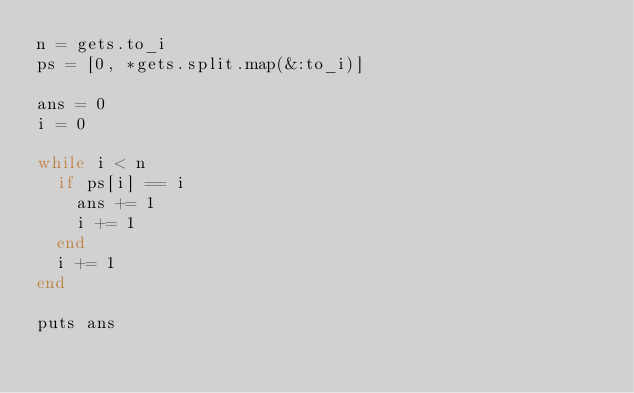Convert code to text. <code><loc_0><loc_0><loc_500><loc_500><_Ruby_>n = gets.to_i
ps = [0, *gets.split.map(&:to_i)]

ans = 0
i = 0

while i < n
  if ps[i] == i
    ans += 1
    i += 1
  end
  i += 1
end

puts ans
</code> 